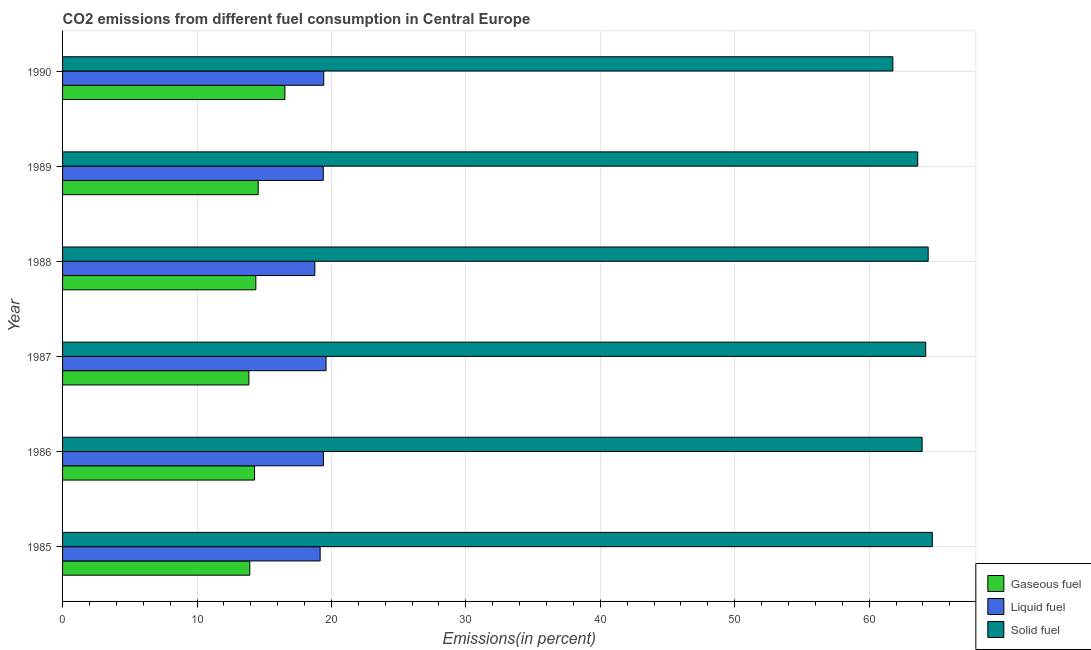How many different coloured bars are there?
Your answer should be very brief. 3. What is the label of the 3rd group of bars from the top?
Keep it short and to the point. 1988. What is the percentage of solid fuel emission in 1990?
Provide a succinct answer. 61.76. Across all years, what is the maximum percentage of solid fuel emission?
Give a very brief answer. 64.7. Across all years, what is the minimum percentage of gaseous fuel emission?
Your response must be concise. 13.86. In which year was the percentage of solid fuel emission maximum?
Give a very brief answer. 1985. What is the total percentage of liquid fuel emission in the graph?
Provide a short and direct response. 115.75. What is the difference between the percentage of liquid fuel emission in 1989 and that in 1990?
Provide a succinct answer. -0.03. What is the difference between the percentage of solid fuel emission in 1985 and the percentage of gaseous fuel emission in 1989?
Keep it short and to the point. 50.15. What is the average percentage of gaseous fuel emission per year?
Make the answer very short. 14.59. In the year 1987, what is the difference between the percentage of liquid fuel emission and percentage of gaseous fuel emission?
Offer a very short reply. 5.74. In how many years, is the percentage of gaseous fuel emission greater than 44 %?
Offer a terse response. 0. What is the ratio of the percentage of liquid fuel emission in 1988 to that in 1990?
Offer a terse response. 0.97. What is the difference between the highest and the second highest percentage of gaseous fuel emission?
Make the answer very short. 1.99. What is the difference between the highest and the lowest percentage of gaseous fuel emission?
Offer a terse response. 2.68. In how many years, is the percentage of solid fuel emission greater than the average percentage of solid fuel emission taken over all years?
Ensure brevity in your answer.  4. What does the 2nd bar from the top in 1988 represents?
Your answer should be compact. Liquid fuel. What does the 3rd bar from the bottom in 1988 represents?
Give a very brief answer. Solid fuel. Is it the case that in every year, the sum of the percentage of gaseous fuel emission and percentage of liquid fuel emission is greater than the percentage of solid fuel emission?
Make the answer very short. No. Are all the bars in the graph horizontal?
Provide a succinct answer. Yes. How many years are there in the graph?
Give a very brief answer. 6. What is the difference between two consecutive major ticks on the X-axis?
Offer a very short reply. 10. Does the graph contain grids?
Offer a terse response. Yes. Where does the legend appear in the graph?
Keep it short and to the point. Bottom right. How many legend labels are there?
Make the answer very short. 3. What is the title of the graph?
Ensure brevity in your answer.  CO2 emissions from different fuel consumption in Central Europe. What is the label or title of the X-axis?
Your answer should be very brief. Emissions(in percent). What is the Emissions(in percent) of Gaseous fuel in 1985?
Give a very brief answer. 13.93. What is the Emissions(in percent) of Liquid fuel in 1985?
Provide a short and direct response. 19.16. What is the Emissions(in percent) in Solid fuel in 1985?
Ensure brevity in your answer.  64.7. What is the Emissions(in percent) of Gaseous fuel in 1986?
Keep it short and to the point. 14.28. What is the Emissions(in percent) of Liquid fuel in 1986?
Offer a very short reply. 19.4. What is the Emissions(in percent) in Solid fuel in 1986?
Provide a succinct answer. 63.94. What is the Emissions(in percent) of Gaseous fuel in 1987?
Make the answer very short. 13.86. What is the Emissions(in percent) in Liquid fuel in 1987?
Your response must be concise. 19.6. What is the Emissions(in percent) of Solid fuel in 1987?
Give a very brief answer. 64.21. What is the Emissions(in percent) in Gaseous fuel in 1988?
Make the answer very short. 14.38. What is the Emissions(in percent) in Liquid fuel in 1988?
Keep it short and to the point. 18.76. What is the Emissions(in percent) in Solid fuel in 1988?
Provide a succinct answer. 64.39. What is the Emissions(in percent) of Gaseous fuel in 1989?
Make the answer very short. 14.55. What is the Emissions(in percent) in Liquid fuel in 1989?
Your answer should be very brief. 19.39. What is the Emissions(in percent) in Solid fuel in 1989?
Provide a succinct answer. 63.61. What is the Emissions(in percent) of Gaseous fuel in 1990?
Make the answer very short. 16.54. What is the Emissions(in percent) of Liquid fuel in 1990?
Give a very brief answer. 19.43. What is the Emissions(in percent) of Solid fuel in 1990?
Ensure brevity in your answer.  61.76. Across all years, what is the maximum Emissions(in percent) in Gaseous fuel?
Give a very brief answer. 16.54. Across all years, what is the maximum Emissions(in percent) in Liquid fuel?
Provide a succinct answer. 19.6. Across all years, what is the maximum Emissions(in percent) in Solid fuel?
Your answer should be compact. 64.7. Across all years, what is the minimum Emissions(in percent) in Gaseous fuel?
Provide a short and direct response. 13.86. Across all years, what is the minimum Emissions(in percent) of Liquid fuel?
Provide a succinct answer. 18.76. Across all years, what is the minimum Emissions(in percent) of Solid fuel?
Give a very brief answer. 61.76. What is the total Emissions(in percent) of Gaseous fuel in the graph?
Provide a succinct answer. 87.53. What is the total Emissions(in percent) of Liquid fuel in the graph?
Your answer should be very brief. 115.75. What is the total Emissions(in percent) of Solid fuel in the graph?
Provide a succinct answer. 382.61. What is the difference between the Emissions(in percent) in Gaseous fuel in 1985 and that in 1986?
Your answer should be compact. -0.35. What is the difference between the Emissions(in percent) of Liquid fuel in 1985 and that in 1986?
Your answer should be very brief. -0.24. What is the difference between the Emissions(in percent) in Solid fuel in 1985 and that in 1986?
Your answer should be compact. 0.76. What is the difference between the Emissions(in percent) in Gaseous fuel in 1985 and that in 1987?
Your response must be concise. 0.07. What is the difference between the Emissions(in percent) of Liquid fuel in 1985 and that in 1987?
Make the answer very short. -0.44. What is the difference between the Emissions(in percent) in Solid fuel in 1985 and that in 1987?
Make the answer very short. 0.49. What is the difference between the Emissions(in percent) in Gaseous fuel in 1985 and that in 1988?
Offer a very short reply. -0.45. What is the difference between the Emissions(in percent) in Liquid fuel in 1985 and that in 1988?
Offer a terse response. 0.4. What is the difference between the Emissions(in percent) of Solid fuel in 1985 and that in 1988?
Provide a short and direct response. 0.31. What is the difference between the Emissions(in percent) in Gaseous fuel in 1985 and that in 1989?
Make the answer very short. -0.62. What is the difference between the Emissions(in percent) of Liquid fuel in 1985 and that in 1989?
Make the answer very short. -0.23. What is the difference between the Emissions(in percent) of Solid fuel in 1985 and that in 1989?
Make the answer very short. 1.09. What is the difference between the Emissions(in percent) of Gaseous fuel in 1985 and that in 1990?
Offer a terse response. -2.61. What is the difference between the Emissions(in percent) of Liquid fuel in 1985 and that in 1990?
Your answer should be very brief. -0.27. What is the difference between the Emissions(in percent) in Solid fuel in 1985 and that in 1990?
Your response must be concise. 2.93. What is the difference between the Emissions(in percent) of Gaseous fuel in 1986 and that in 1987?
Keep it short and to the point. 0.42. What is the difference between the Emissions(in percent) in Liquid fuel in 1986 and that in 1987?
Make the answer very short. -0.19. What is the difference between the Emissions(in percent) of Solid fuel in 1986 and that in 1987?
Provide a succinct answer. -0.27. What is the difference between the Emissions(in percent) of Gaseous fuel in 1986 and that in 1988?
Your answer should be compact. -0.09. What is the difference between the Emissions(in percent) in Liquid fuel in 1986 and that in 1988?
Give a very brief answer. 0.64. What is the difference between the Emissions(in percent) of Solid fuel in 1986 and that in 1988?
Give a very brief answer. -0.45. What is the difference between the Emissions(in percent) in Gaseous fuel in 1986 and that in 1989?
Keep it short and to the point. -0.27. What is the difference between the Emissions(in percent) in Liquid fuel in 1986 and that in 1989?
Offer a terse response. 0.01. What is the difference between the Emissions(in percent) in Solid fuel in 1986 and that in 1989?
Your response must be concise. 0.33. What is the difference between the Emissions(in percent) of Gaseous fuel in 1986 and that in 1990?
Make the answer very short. -2.26. What is the difference between the Emissions(in percent) in Liquid fuel in 1986 and that in 1990?
Keep it short and to the point. -0.02. What is the difference between the Emissions(in percent) of Solid fuel in 1986 and that in 1990?
Keep it short and to the point. 2.18. What is the difference between the Emissions(in percent) in Gaseous fuel in 1987 and that in 1988?
Give a very brief answer. -0.52. What is the difference between the Emissions(in percent) of Liquid fuel in 1987 and that in 1988?
Ensure brevity in your answer.  0.83. What is the difference between the Emissions(in percent) in Solid fuel in 1987 and that in 1988?
Your response must be concise. -0.18. What is the difference between the Emissions(in percent) of Gaseous fuel in 1987 and that in 1989?
Your answer should be very brief. -0.69. What is the difference between the Emissions(in percent) of Liquid fuel in 1987 and that in 1989?
Your answer should be very brief. 0.2. What is the difference between the Emissions(in percent) in Solid fuel in 1987 and that in 1989?
Offer a very short reply. 0.59. What is the difference between the Emissions(in percent) in Gaseous fuel in 1987 and that in 1990?
Give a very brief answer. -2.68. What is the difference between the Emissions(in percent) in Liquid fuel in 1987 and that in 1990?
Provide a succinct answer. 0.17. What is the difference between the Emissions(in percent) in Solid fuel in 1987 and that in 1990?
Provide a short and direct response. 2.44. What is the difference between the Emissions(in percent) in Gaseous fuel in 1988 and that in 1989?
Ensure brevity in your answer.  -0.17. What is the difference between the Emissions(in percent) of Liquid fuel in 1988 and that in 1989?
Offer a very short reply. -0.63. What is the difference between the Emissions(in percent) in Solid fuel in 1988 and that in 1989?
Make the answer very short. 0.78. What is the difference between the Emissions(in percent) of Gaseous fuel in 1988 and that in 1990?
Your answer should be compact. -2.16. What is the difference between the Emissions(in percent) in Liquid fuel in 1988 and that in 1990?
Your response must be concise. -0.66. What is the difference between the Emissions(in percent) of Solid fuel in 1988 and that in 1990?
Your answer should be compact. 2.62. What is the difference between the Emissions(in percent) in Gaseous fuel in 1989 and that in 1990?
Ensure brevity in your answer.  -1.99. What is the difference between the Emissions(in percent) in Liquid fuel in 1989 and that in 1990?
Give a very brief answer. -0.03. What is the difference between the Emissions(in percent) of Solid fuel in 1989 and that in 1990?
Provide a short and direct response. 1.85. What is the difference between the Emissions(in percent) in Gaseous fuel in 1985 and the Emissions(in percent) in Liquid fuel in 1986?
Give a very brief answer. -5.48. What is the difference between the Emissions(in percent) of Gaseous fuel in 1985 and the Emissions(in percent) of Solid fuel in 1986?
Your response must be concise. -50.01. What is the difference between the Emissions(in percent) in Liquid fuel in 1985 and the Emissions(in percent) in Solid fuel in 1986?
Provide a succinct answer. -44.78. What is the difference between the Emissions(in percent) in Gaseous fuel in 1985 and the Emissions(in percent) in Liquid fuel in 1987?
Ensure brevity in your answer.  -5.67. What is the difference between the Emissions(in percent) in Gaseous fuel in 1985 and the Emissions(in percent) in Solid fuel in 1987?
Your response must be concise. -50.28. What is the difference between the Emissions(in percent) in Liquid fuel in 1985 and the Emissions(in percent) in Solid fuel in 1987?
Keep it short and to the point. -45.04. What is the difference between the Emissions(in percent) in Gaseous fuel in 1985 and the Emissions(in percent) in Liquid fuel in 1988?
Make the answer very short. -4.84. What is the difference between the Emissions(in percent) of Gaseous fuel in 1985 and the Emissions(in percent) of Solid fuel in 1988?
Keep it short and to the point. -50.46. What is the difference between the Emissions(in percent) in Liquid fuel in 1985 and the Emissions(in percent) in Solid fuel in 1988?
Your answer should be compact. -45.23. What is the difference between the Emissions(in percent) of Gaseous fuel in 1985 and the Emissions(in percent) of Liquid fuel in 1989?
Make the answer very short. -5.47. What is the difference between the Emissions(in percent) of Gaseous fuel in 1985 and the Emissions(in percent) of Solid fuel in 1989?
Provide a succinct answer. -49.69. What is the difference between the Emissions(in percent) in Liquid fuel in 1985 and the Emissions(in percent) in Solid fuel in 1989?
Your response must be concise. -44.45. What is the difference between the Emissions(in percent) in Gaseous fuel in 1985 and the Emissions(in percent) in Liquid fuel in 1990?
Give a very brief answer. -5.5. What is the difference between the Emissions(in percent) in Gaseous fuel in 1985 and the Emissions(in percent) in Solid fuel in 1990?
Offer a terse response. -47.84. What is the difference between the Emissions(in percent) in Liquid fuel in 1985 and the Emissions(in percent) in Solid fuel in 1990?
Offer a very short reply. -42.6. What is the difference between the Emissions(in percent) in Gaseous fuel in 1986 and the Emissions(in percent) in Liquid fuel in 1987?
Your response must be concise. -5.32. What is the difference between the Emissions(in percent) of Gaseous fuel in 1986 and the Emissions(in percent) of Solid fuel in 1987?
Keep it short and to the point. -49.92. What is the difference between the Emissions(in percent) of Liquid fuel in 1986 and the Emissions(in percent) of Solid fuel in 1987?
Give a very brief answer. -44.8. What is the difference between the Emissions(in percent) in Gaseous fuel in 1986 and the Emissions(in percent) in Liquid fuel in 1988?
Provide a succinct answer. -4.48. What is the difference between the Emissions(in percent) in Gaseous fuel in 1986 and the Emissions(in percent) in Solid fuel in 1988?
Offer a very short reply. -50.11. What is the difference between the Emissions(in percent) of Liquid fuel in 1986 and the Emissions(in percent) of Solid fuel in 1988?
Your answer should be very brief. -44.98. What is the difference between the Emissions(in percent) in Gaseous fuel in 1986 and the Emissions(in percent) in Liquid fuel in 1989?
Your response must be concise. -5.11. What is the difference between the Emissions(in percent) of Gaseous fuel in 1986 and the Emissions(in percent) of Solid fuel in 1989?
Your answer should be compact. -49.33. What is the difference between the Emissions(in percent) of Liquid fuel in 1986 and the Emissions(in percent) of Solid fuel in 1989?
Provide a succinct answer. -44.21. What is the difference between the Emissions(in percent) of Gaseous fuel in 1986 and the Emissions(in percent) of Liquid fuel in 1990?
Make the answer very short. -5.15. What is the difference between the Emissions(in percent) of Gaseous fuel in 1986 and the Emissions(in percent) of Solid fuel in 1990?
Your answer should be very brief. -47.48. What is the difference between the Emissions(in percent) of Liquid fuel in 1986 and the Emissions(in percent) of Solid fuel in 1990?
Offer a very short reply. -42.36. What is the difference between the Emissions(in percent) of Gaseous fuel in 1987 and the Emissions(in percent) of Liquid fuel in 1988?
Offer a very short reply. -4.91. What is the difference between the Emissions(in percent) in Gaseous fuel in 1987 and the Emissions(in percent) in Solid fuel in 1988?
Offer a very short reply. -50.53. What is the difference between the Emissions(in percent) in Liquid fuel in 1987 and the Emissions(in percent) in Solid fuel in 1988?
Give a very brief answer. -44.79. What is the difference between the Emissions(in percent) in Gaseous fuel in 1987 and the Emissions(in percent) in Liquid fuel in 1989?
Keep it short and to the point. -5.54. What is the difference between the Emissions(in percent) of Gaseous fuel in 1987 and the Emissions(in percent) of Solid fuel in 1989?
Give a very brief answer. -49.75. What is the difference between the Emissions(in percent) of Liquid fuel in 1987 and the Emissions(in percent) of Solid fuel in 1989?
Ensure brevity in your answer.  -44.01. What is the difference between the Emissions(in percent) in Gaseous fuel in 1987 and the Emissions(in percent) in Liquid fuel in 1990?
Your answer should be very brief. -5.57. What is the difference between the Emissions(in percent) of Gaseous fuel in 1987 and the Emissions(in percent) of Solid fuel in 1990?
Your response must be concise. -47.9. What is the difference between the Emissions(in percent) in Liquid fuel in 1987 and the Emissions(in percent) in Solid fuel in 1990?
Your answer should be very brief. -42.16. What is the difference between the Emissions(in percent) in Gaseous fuel in 1988 and the Emissions(in percent) in Liquid fuel in 1989?
Ensure brevity in your answer.  -5.02. What is the difference between the Emissions(in percent) of Gaseous fuel in 1988 and the Emissions(in percent) of Solid fuel in 1989?
Offer a terse response. -49.24. What is the difference between the Emissions(in percent) in Liquid fuel in 1988 and the Emissions(in percent) in Solid fuel in 1989?
Make the answer very short. -44.85. What is the difference between the Emissions(in percent) in Gaseous fuel in 1988 and the Emissions(in percent) in Liquid fuel in 1990?
Your answer should be very brief. -5.05. What is the difference between the Emissions(in percent) in Gaseous fuel in 1988 and the Emissions(in percent) in Solid fuel in 1990?
Your answer should be very brief. -47.39. What is the difference between the Emissions(in percent) of Liquid fuel in 1988 and the Emissions(in percent) of Solid fuel in 1990?
Offer a very short reply. -43. What is the difference between the Emissions(in percent) in Gaseous fuel in 1989 and the Emissions(in percent) in Liquid fuel in 1990?
Offer a very short reply. -4.88. What is the difference between the Emissions(in percent) of Gaseous fuel in 1989 and the Emissions(in percent) of Solid fuel in 1990?
Offer a very short reply. -47.21. What is the difference between the Emissions(in percent) of Liquid fuel in 1989 and the Emissions(in percent) of Solid fuel in 1990?
Ensure brevity in your answer.  -42.37. What is the average Emissions(in percent) in Gaseous fuel per year?
Offer a very short reply. 14.59. What is the average Emissions(in percent) of Liquid fuel per year?
Your answer should be very brief. 19.29. What is the average Emissions(in percent) of Solid fuel per year?
Ensure brevity in your answer.  63.77. In the year 1985, what is the difference between the Emissions(in percent) of Gaseous fuel and Emissions(in percent) of Liquid fuel?
Your answer should be very brief. -5.23. In the year 1985, what is the difference between the Emissions(in percent) in Gaseous fuel and Emissions(in percent) in Solid fuel?
Give a very brief answer. -50.77. In the year 1985, what is the difference between the Emissions(in percent) in Liquid fuel and Emissions(in percent) in Solid fuel?
Offer a terse response. -45.54. In the year 1986, what is the difference between the Emissions(in percent) in Gaseous fuel and Emissions(in percent) in Liquid fuel?
Offer a terse response. -5.12. In the year 1986, what is the difference between the Emissions(in percent) of Gaseous fuel and Emissions(in percent) of Solid fuel?
Ensure brevity in your answer.  -49.66. In the year 1986, what is the difference between the Emissions(in percent) in Liquid fuel and Emissions(in percent) in Solid fuel?
Offer a terse response. -44.54. In the year 1987, what is the difference between the Emissions(in percent) in Gaseous fuel and Emissions(in percent) in Liquid fuel?
Provide a succinct answer. -5.74. In the year 1987, what is the difference between the Emissions(in percent) of Gaseous fuel and Emissions(in percent) of Solid fuel?
Your response must be concise. -50.35. In the year 1987, what is the difference between the Emissions(in percent) of Liquid fuel and Emissions(in percent) of Solid fuel?
Ensure brevity in your answer.  -44.61. In the year 1988, what is the difference between the Emissions(in percent) in Gaseous fuel and Emissions(in percent) in Liquid fuel?
Make the answer very short. -4.39. In the year 1988, what is the difference between the Emissions(in percent) of Gaseous fuel and Emissions(in percent) of Solid fuel?
Give a very brief answer. -50.01. In the year 1988, what is the difference between the Emissions(in percent) of Liquid fuel and Emissions(in percent) of Solid fuel?
Keep it short and to the point. -45.62. In the year 1989, what is the difference between the Emissions(in percent) of Gaseous fuel and Emissions(in percent) of Liquid fuel?
Ensure brevity in your answer.  -4.84. In the year 1989, what is the difference between the Emissions(in percent) in Gaseous fuel and Emissions(in percent) in Solid fuel?
Ensure brevity in your answer.  -49.06. In the year 1989, what is the difference between the Emissions(in percent) in Liquid fuel and Emissions(in percent) in Solid fuel?
Make the answer very short. -44.22. In the year 1990, what is the difference between the Emissions(in percent) in Gaseous fuel and Emissions(in percent) in Liquid fuel?
Your answer should be compact. -2.89. In the year 1990, what is the difference between the Emissions(in percent) in Gaseous fuel and Emissions(in percent) in Solid fuel?
Provide a succinct answer. -45.22. In the year 1990, what is the difference between the Emissions(in percent) in Liquid fuel and Emissions(in percent) in Solid fuel?
Your response must be concise. -42.34. What is the ratio of the Emissions(in percent) in Gaseous fuel in 1985 to that in 1986?
Give a very brief answer. 0.98. What is the ratio of the Emissions(in percent) in Liquid fuel in 1985 to that in 1986?
Provide a succinct answer. 0.99. What is the ratio of the Emissions(in percent) of Solid fuel in 1985 to that in 1986?
Your answer should be very brief. 1.01. What is the ratio of the Emissions(in percent) of Gaseous fuel in 1985 to that in 1987?
Keep it short and to the point. 1. What is the ratio of the Emissions(in percent) in Liquid fuel in 1985 to that in 1987?
Your response must be concise. 0.98. What is the ratio of the Emissions(in percent) in Solid fuel in 1985 to that in 1987?
Keep it short and to the point. 1.01. What is the ratio of the Emissions(in percent) of Gaseous fuel in 1985 to that in 1988?
Your answer should be very brief. 0.97. What is the ratio of the Emissions(in percent) of Liquid fuel in 1985 to that in 1988?
Provide a short and direct response. 1.02. What is the ratio of the Emissions(in percent) in Solid fuel in 1985 to that in 1988?
Give a very brief answer. 1. What is the ratio of the Emissions(in percent) in Gaseous fuel in 1985 to that in 1989?
Provide a succinct answer. 0.96. What is the ratio of the Emissions(in percent) of Liquid fuel in 1985 to that in 1989?
Provide a short and direct response. 0.99. What is the ratio of the Emissions(in percent) of Solid fuel in 1985 to that in 1989?
Provide a short and direct response. 1.02. What is the ratio of the Emissions(in percent) in Gaseous fuel in 1985 to that in 1990?
Give a very brief answer. 0.84. What is the ratio of the Emissions(in percent) in Liquid fuel in 1985 to that in 1990?
Your answer should be very brief. 0.99. What is the ratio of the Emissions(in percent) in Solid fuel in 1985 to that in 1990?
Keep it short and to the point. 1.05. What is the ratio of the Emissions(in percent) in Gaseous fuel in 1986 to that in 1987?
Ensure brevity in your answer.  1.03. What is the ratio of the Emissions(in percent) of Liquid fuel in 1986 to that in 1987?
Keep it short and to the point. 0.99. What is the ratio of the Emissions(in percent) in Solid fuel in 1986 to that in 1987?
Your answer should be very brief. 1. What is the ratio of the Emissions(in percent) of Gaseous fuel in 1986 to that in 1988?
Give a very brief answer. 0.99. What is the ratio of the Emissions(in percent) of Liquid fuel in 1986 to that in 1988?
Keep it short and to the point. 1.03. What is the ratio of the Emissions(in percent) of Solid fuel in 1986 to that in 1988?
Provide a short and direct response. 0.99. What is the ratio of the Emissions(in percent) in Gaseous fuel in 1986 to that in 1989?
Provide a succinct answer. 0.98. What is the ratio of the Emissions(in percent) in Solid fuel in 1986 to that in 1989?
Offer a very short reply. 1.01. What is the ratio of the Emissions(in percent) of Gaseous fuel in 1986 to that in 1990?
Make the answer very short. 0.86. What is the ratio of the Emissions(in percent) of Liquid fuel in 1986 to that in 1990?
Give a very brief answer. 1. What is the ratio of the Emissions(in percent) in Solid fuel in 1986 to that in 1990?
Your response must be concise. 1.04. What is the ratio of the Emissions(in percent) of Gaseous fuel in 1987 to that in 1988?
Ensure brevity in your answer.  0.96. What is the ratio of the Emissions(in percent) in Liquid fuel in 1987 to that in 1988?
Your answer should be compact. 1.04. What is the ratio of the Emissions(in percent) of Gaseous fuel in 1987 to that in 1989?
Offer a very short reply. 0.95. What is the ratio of the Emissions(in percent) in Liquid fuel in 1987 to that in 1989?
Your answer should be very brief. 1.01. What is the ratio of the Emissions(in percent) of Solid fuel in 1987 to that in 1989?
Make the answer very short. 1.01. What is the ratio of the Emissions(in percent) in Gaseous fuel in 1987 to that in 1990?
Your answer should be very brief. 0.84. What is the ratio of the Emissions(in percent) in Liquid fuel in 1987 to that in 1990?
Your response must be concise. 1.01. What is the ratio of the Emissions(in percent) in Solid fuel in 1987 to that in 1990?
Provide a short and direct response. 1.04. What is the ratio of the Emissions(in percent) of Gaseous fuel in 1988 to that in 1989?
Ensure brevity in your answer.  0.99. What is the ratio of the Emissions(in percent) in Liquid fuel in 1988 to that in 1989?
Provide a succinct answer. 0.97. What is the ratio of the Emissions(in percent) of Solid fuel in 1988 to that in 1989?
Ensure brevity in your answer.  1.01. What is the ratio of the Emissions(in percent) in Gaseous fuel in 1988 to that in 1990?
Give a very brief answer. 0.87. What is the ratio of the Emissions(in percent) of Liquid fuel in 1988 to that in 1990?
Offer a very short reply. 0.97. What is the ratio of the Emissions(in percent) in Solid fuel in 1988 to that in 1990?
Your response must be concise. 1.04. What is the ratio of the Emissions(in percent) of Gaseous fuel in 1989 to that in 1990?
Offer a very short reply. 0.88. What is the ratio of the Emissions(in percent) in Liquid fuel in 1989 to that in 1990?
Your answer should be compact. 1. What is the ratio of the Emissions(in percent) in Solid fuel in 1989 to that in 1990?
Ensure brevity in your answer.  1.03. What is the difference between the highest and the second highest Emissions(in percent) of Gaseous fuel?
Provide a succinct answer. 1.99. What is the difference between the highest and the second highest Emissions(in percent) of Liquid fuel?
Offer a terse response. 0.17. What is the difference between the highest and the second highest Emissions(in percent) in Solid fuel?
Your response must be concise. 0.31. What is the difference between the highest and the lowest Emissions(in percent) in Gaseous fuel?
Provide a short and direct response. 2.68. What is the difference between the highest and the lowest Emissions(in percent) in Liquid fuel?
Provide a succinct answer. 0.83. What is the difference between the highest and the lowest Emissions(in percent) in Solid fuel?
Give a very brief answer. 2.93. 